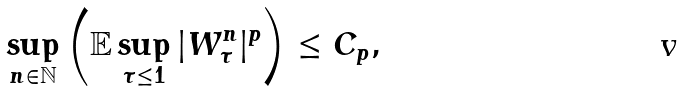Convert formula to latex. <formula><loc_0><loc_0><loc_500><loc_500>\sup _ { n \in \mathbb { N } } \left ( \mathbb { E } \sup _ { \tau \leq 1 } | W _ { \tau } ^ { n } | ^ { p } \right ) \leq C _ { p } ,</formula> 